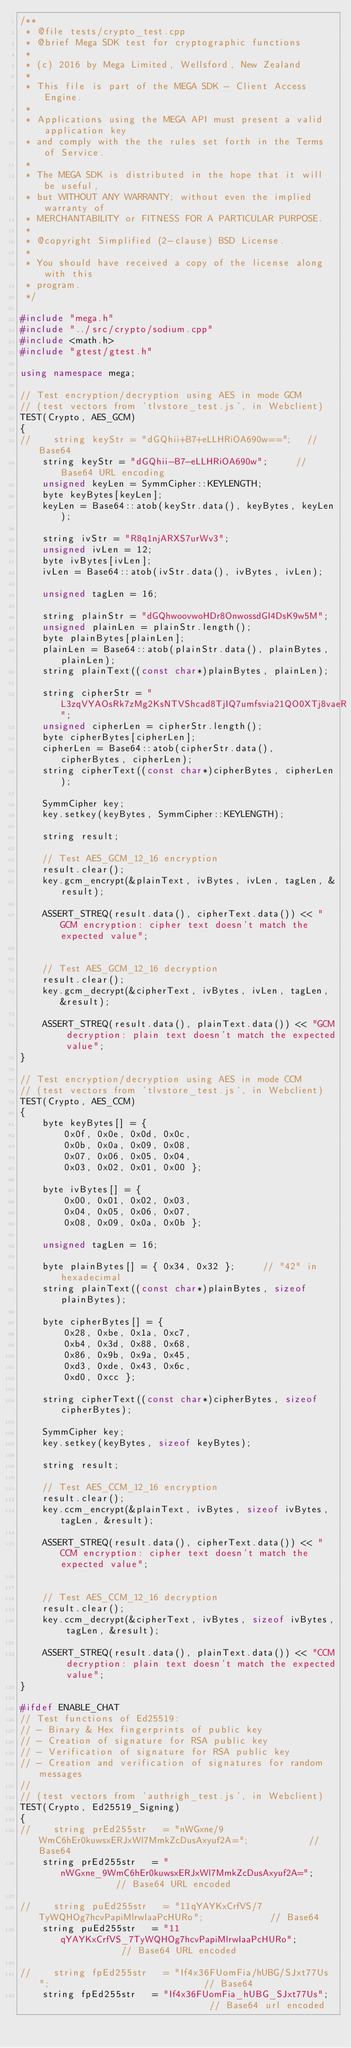<code> <loc_0><loc_0><loc_500><loc_500><_C++_>/**
 * @file tests/crypto_test.cpp
 * @brief Mega SDK test for cryptographic functions
 *
 * (c) 2016 by Mega Limited, Wellsford, New Zealand
 *
 * This file is part of the MEGA SDK - Client Access Engine.
 *
 * Applications using the MEGA API must present a valid application key
 * and comply with the the rules set forth in the Terms of Service.
 *
 * The MEGA SDK is distributed in the hope that it will be useful,
 * but WITHOUT ANY WARRANTY; without even the implied warranty of
 * MERCHANTABILITY or FITNESS FOR A PARTICULAR PURPOSE.
 *
 * @copyright Simplified (2-clause) BSD License.
 *
 * You should have received a copy of the license along with this
 * program.
 */

#include "mega.h"
#include "../src/crypto/sodium.cpp"
#include <math.h>
#include "gtest/gtest.h"

using namespace mega;

// Test encryption/decryption using AES in mode GCM
// (test vectors from 'tlvstore_test.js', in Webclient)
TEST(Crypto, AES_GCM)
{
//    string keyStr = "dGQhii+B7+eLLHRiOA690w==";   // Base64
    string keyStr = "dGQhii-B7-eLLHRiOA690w";     // Base64 URL encoding
    unsigned keyLen = SymmCipher::KEYLENGTH;
    byte keyBytes[keyLen];
    keyLen = Base64::atob(keyStr.data(), keyBytes, keyLen);

    string ivStr = "R8q1njARXS7urWv3";
    unsigned ivLen = 12;
    byte ivBytes[ivLen];
    ivLen = Base64::atob(ivStr.data(), ivBytes, ivLen);

    unsigned tagLen = 16;

    string plainStr = "dGQhwoovwoHDr8OnwossdGI4DsK9w5M";
    unsigned plainLen = plainStr.length();
    byte plainBytes[plainLen];
    plainLen = Base64::atob(plainStr.data(), plainBytes, plainLen);
    string plainText((const char*)plainBytes, plainLen);

    string cipherStr = "L3zqVYAOsRk7zMg2KsNTVShcad8TjIQ7umfsvia21QO0XTj8vaeR";
    unsigned cipherLen = cipherStr.length();
    byte cipherBytes[cipherLen];
    cipherLen = Base64::atob(cipherStr.data(), cipherBytes, cipherLen);
    string cipherText((const char*)cipherBytes, cipherLen);

    SymmCipher key;
    key.setkey(keyBytes, SymmCipher::KEYLENGTH);

    string result;

    // Test AES_GCM_12_16 encryption
    result.clear();
    key.gcm_encrypt(&plainText, ivBytes, ivLen, tagLen, &result);

    ASSERT_STREQ(result.data(), cipherText.data()) << "GCM encryption: cipher text doesn't match the expected value";


    // Test AES_GCM_12_16 decryption
    result.clear();
    key.gcm_decrypt(&cipherText, ivBytes, ivLen, tagLen, &result);

    ASSERT_STREQ(result.data(), plainText.data()) << "GCM decryption: plain text doesn't match the expected value";
}

// Test encryption/decryption using AES in mode CCM
// (test vectors from 'tlvstore_test.js', in Webclient)
TEST(Crypto, AES_CCM)
{
    byte keyBytes[] = {
        0x0f, 0x0e, 0x0d, 0x0c,
        0x0b, 0x0a, 0x09, 0x08,
        0x07, 0x06, 0x05, 0x04,
        0x03, 0x02, 0x01, 0x00 };

    byte ivBytes[] = {
        0x00, 0x01, 0x02, 0x03,
        0x04, 0x05, 0x06, 0x07,
        0x08, 0x09, 0x0a, 0x0b };

    unsigned tagLen = 16;

    byte plainBytes[] = { 0x34, 0x32 };     // "42" in hexadecimal
    string plainText((const char*)plainBytes, sizeof plainBytes);

    byte cipherBytes[] = {
        0x28, 0xbe, 0x1a, 0xc7,
        0xb4, 0x3d, 0x88, 0x68,
        0x86, 0x9b, 0x9a, 0x45,
        0xd3, 0xde, 0x43, 0x6c,
        0xd0, 0xcc };

    string cipherText((const char*)cipherBytes, sizeof cipherBytes);

    SymmCipher key;
    key.setkey(keyBytes, sizeof keyBytes);

    string result;

    // Test AES_CCM_12_16 encryption
    result.clear();
    key.ccm_encrypt(&plainText, ivBytes, sizeof ivBytes, tagLen, &result);

    ASSERT_STREQ(result.data(), cipherText.data()) << "CCM encryption: cipher text doesn't match the expected value";


    // Test AES_CCM_12_16 decryption
    result.clear();
    key.ccm_decrypt(&cipherText, ivBytes, sizeof ivBytes, tagLen, &result);

    ASSERT_STREQ(result.data(), plainText.data()) << "CCM decryption: plain text doesn't match the expected value";
}

#ifdef ENABLE_CHAT
// Test functions of Ed25519:
// - Binary & Hex fingerprints of public key
// - Creation of signature for RSA public key
// - Verification of signature for RSA public key
// - Creation and verification of signatures for random messages
//
// (test vectors from 'authrigh_test.js', in Webclient)
TEST(Crypto, Ed25519_Signing)
{
//    string prEd255str   = "nWGxne/9WmC6hEr0kuwsxERJxWl7MmkZcDusAxyuf2A=";           // Base64
    string prEd255str   = "nWGxne_9WmC6hEr0kuwsxERJxWl7MmkZcDusAxyuf2A=";           // Base64 URL encoded

//    string puEd255str   = "11qYAYKxCrfVS/7TyWQHOg7hcvPapiMlrwIaaPcHURo";            // Base64
    string puEd255str   = "11qYAYKxCrfVS_7TyWQHOg7hcvPapiMlrwIaaPcHURo";            // Base64 URL encoded

//    string fpEd255str   = "If4x36FUomFia/hUBG/SJxt77Us";                            // Base64
    string fpEd255str   = "If4x36FUomFia_hUBG_SJxt77Us";                            // Base64 url encoded</code> 